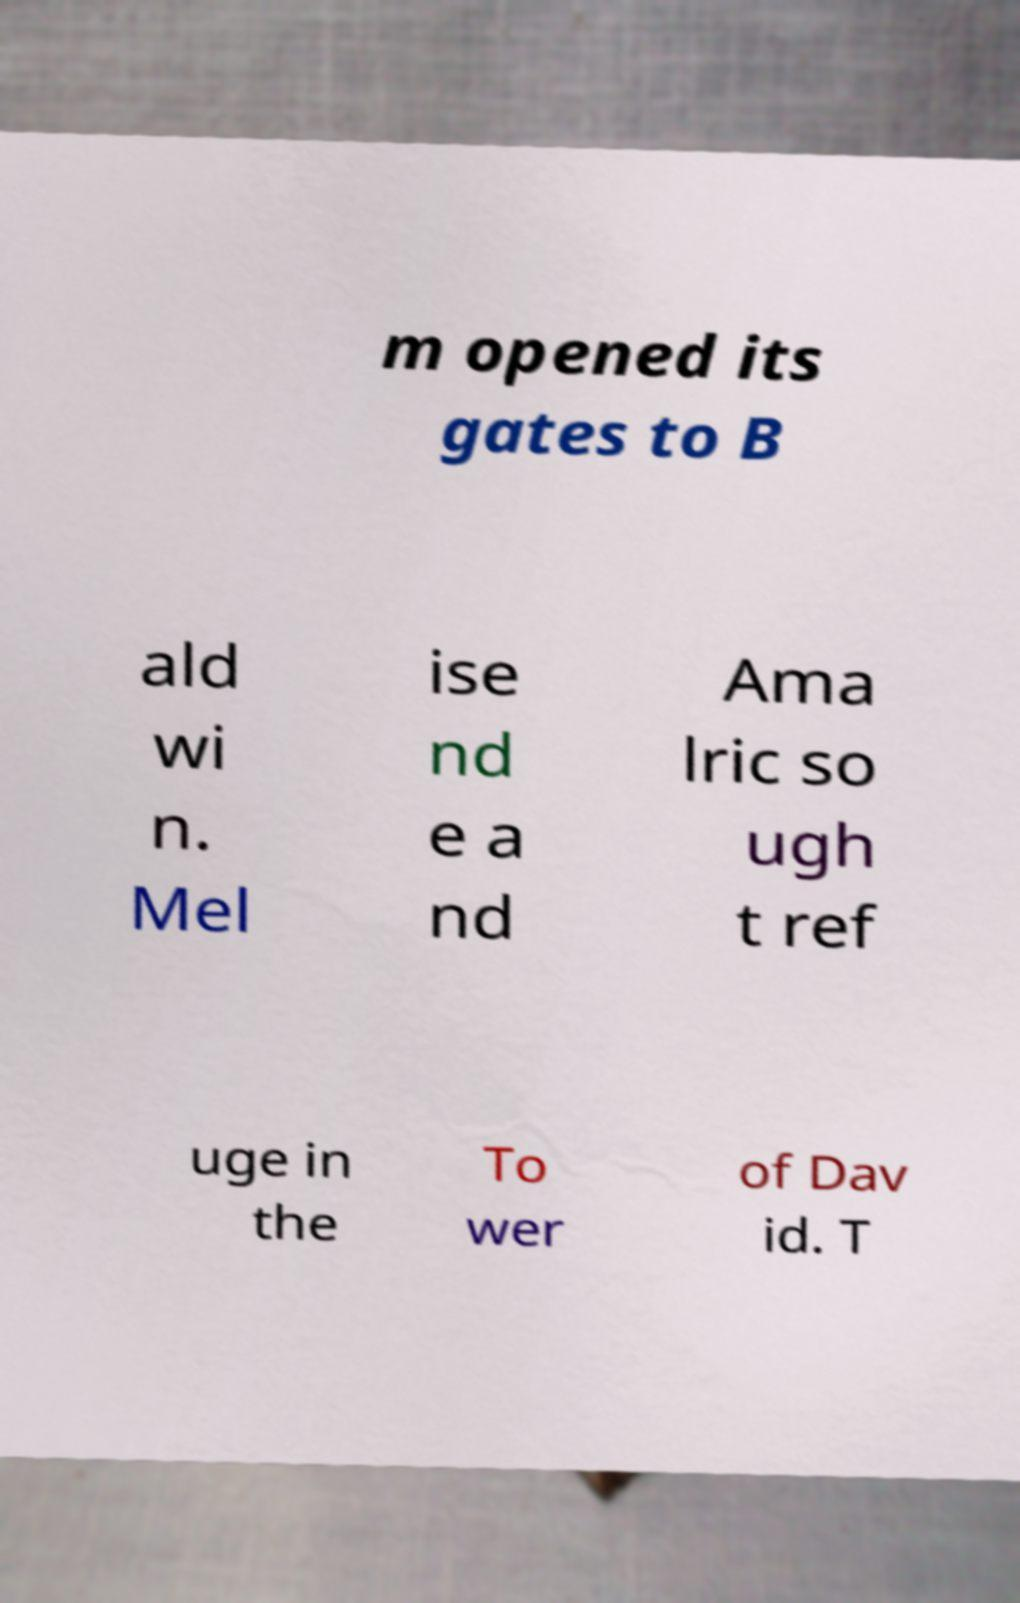Can you accurately transcribe the text from the provided image for me? m opened its gates to B ald wi n. Mel ise nd e a nd Ama lric so ugh t ref uge in the To wer of Dav id. T 